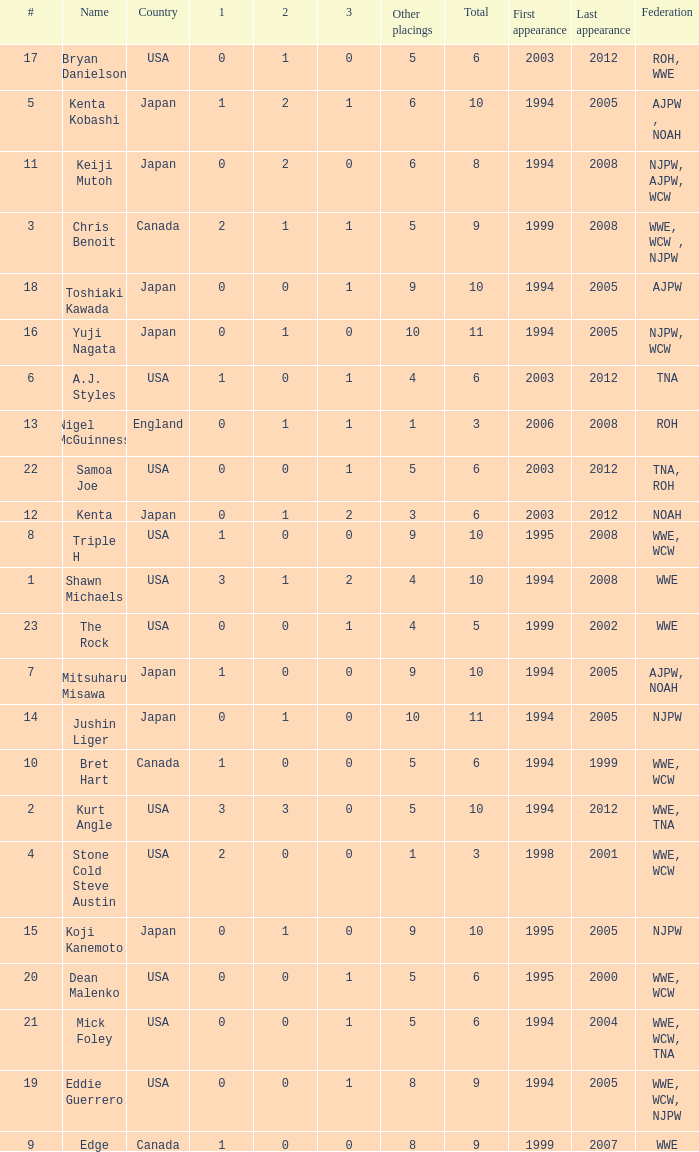How many times has a wrestler whose federation was roh, wwe competed in this event? 1.0. 